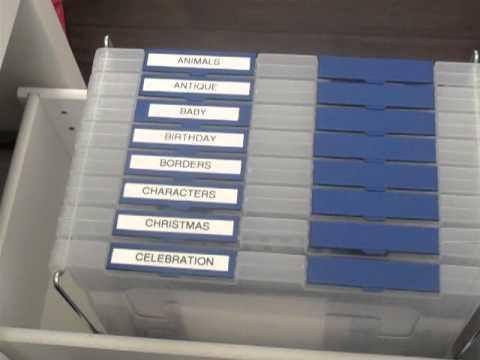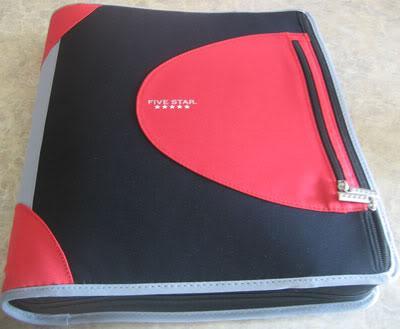The first image is the image on the left, the second image is the image on the right. For the images displayed, is the sentence "The left image shows one blue-toned binder." factually correct? Answer yes or no. No. 